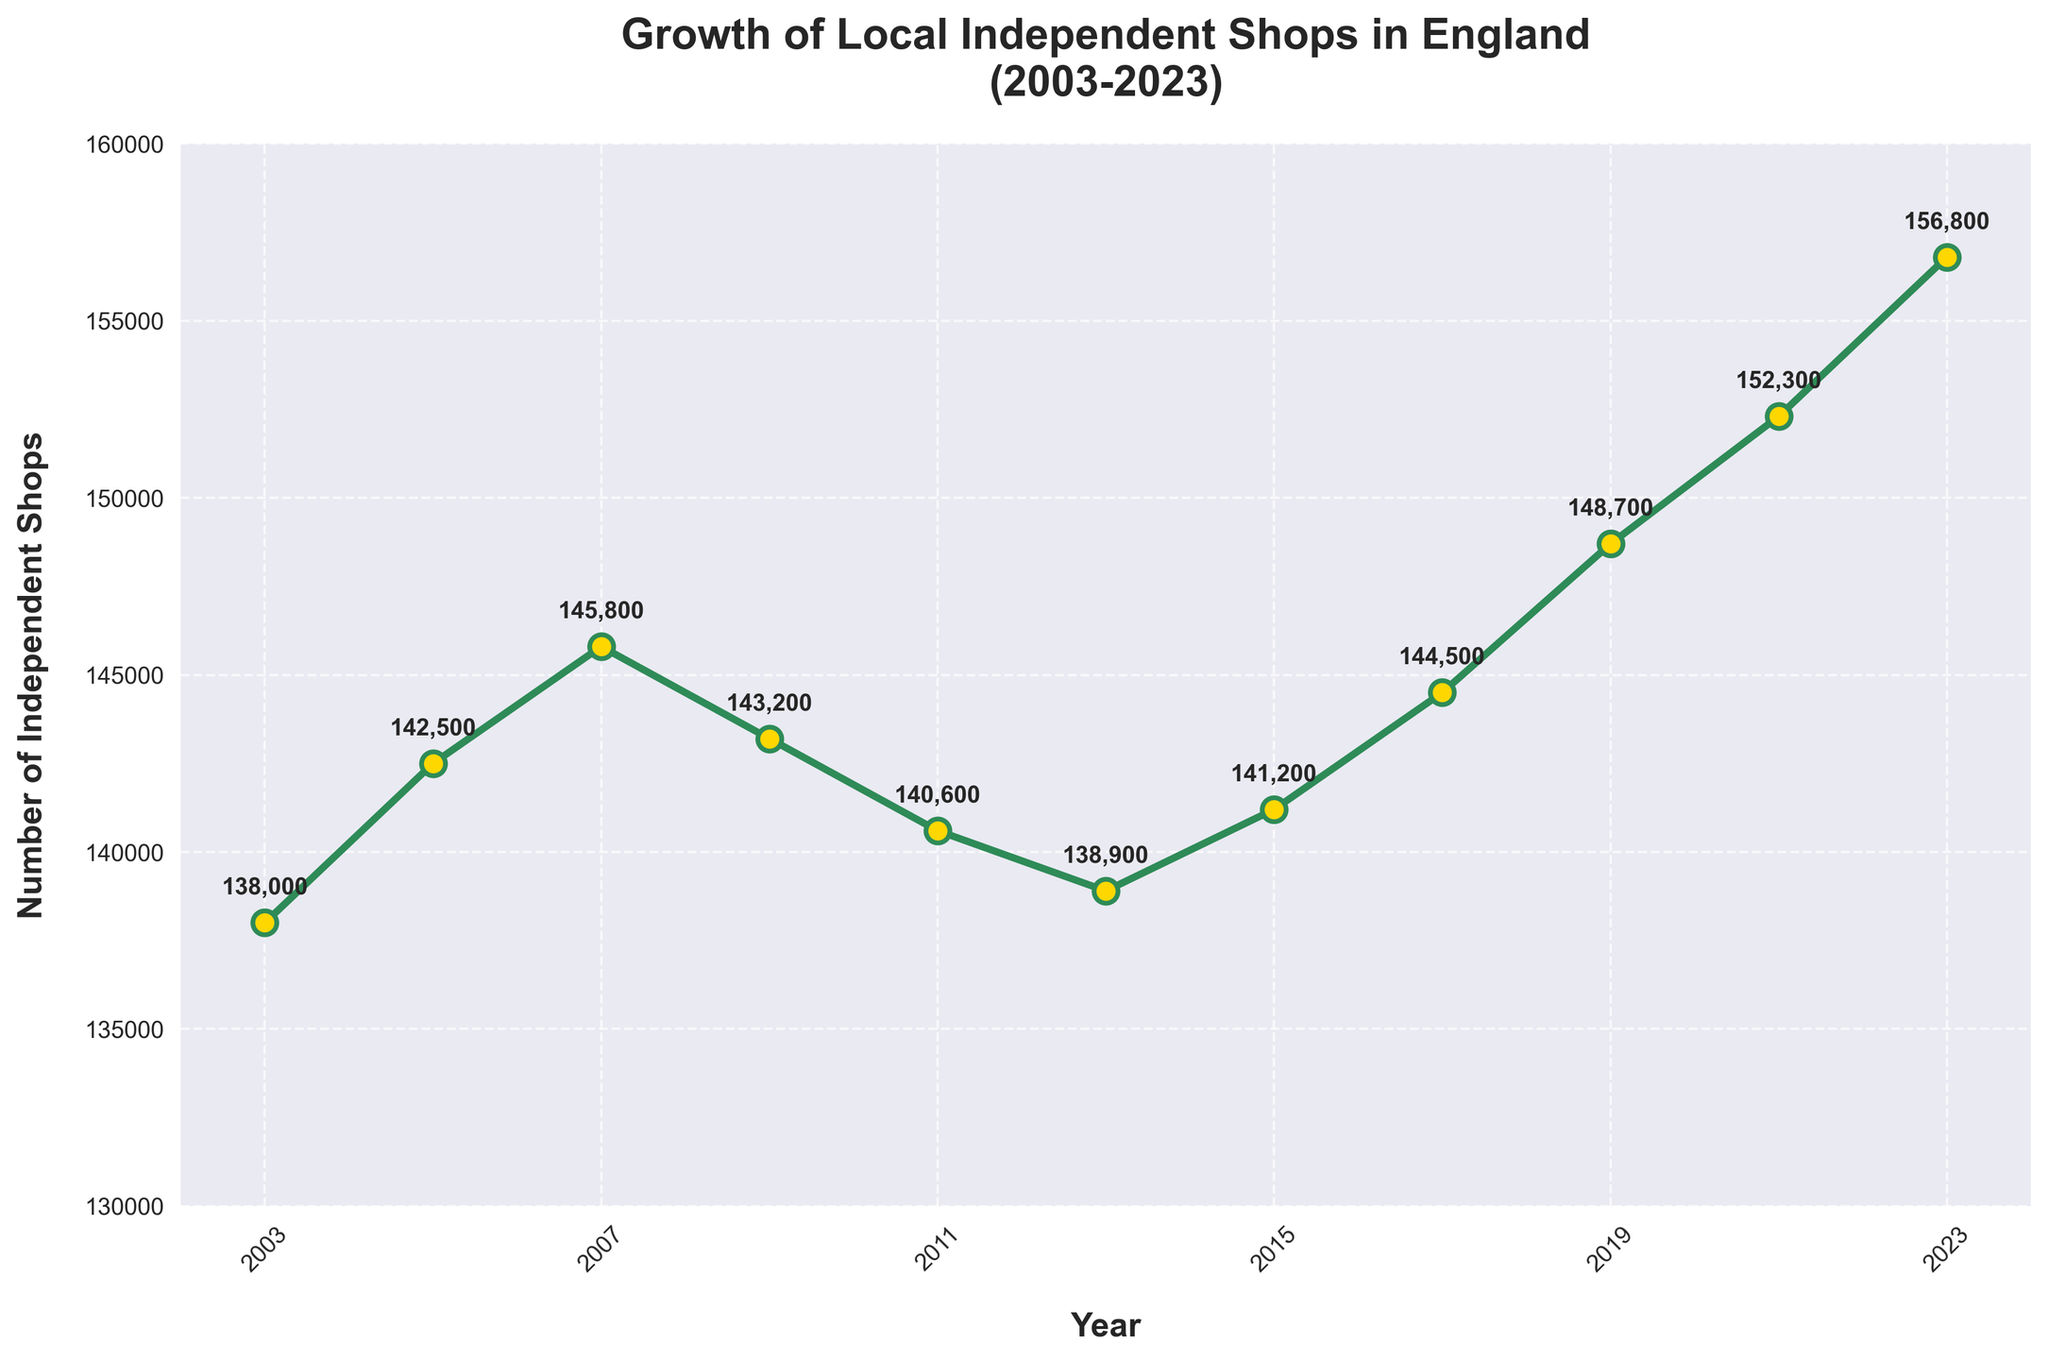What year had the highest number of independent shops? The year 2023 had the highest number of independent shops at 156,800. This is evident from the highest data point on the graph.
Answer: 2023 What is the difference in the number of independent shops between 2003 and 2023? To find the difference, subtract the number of independent shops in 2003 (138,000) from that in 2023 (156,800). 156,800 - 138,000 = 18,800.
Answer: 18,800 In which period did the number of shops decrease the most? The most significant decrease occurred between 2007 and 2009. The number of shops dropped from 145,800 in 2007 to 143,200 in 2009. The difference is 145,800 - 143,200 = 2,600.
Answer: Between 2007 and 2009 What is the average number of shops from 2003 to 2023? To calculate the average, sum the numbers for all the years and then divide by the number of years. Sum = 138,000 + 142,500 + 145,800 + 143,200 + 140,600 + 138,900 + 141,200 + 144,500 + 148,700 + 152,300 + 156,800 = 1,592,500. There are 11 years, so 1,592,500 / 11 = 144,772.7.
Answer: 144,772.7 Did the number of shops ever dip below 140,000? Yes, in 2013, the number of shops was 138,900, which is below 140,000. This can be seen as the lowest point on the graph.
Answer: Yes Was there ever a period where the number of shops remained the same or decreased consecutively for three years or more? No, the graph indicates that while there were periods of decrease, none lasted for three consecutive years.
Answer: No How does the growth trend from 2019 to 2023 compare to the trend from 2005 to 2007? From 2019 to 2023, the number of shops increased from 148,700 to 156,800, which is a growth of 8,100 shops. From 2005 to 2007, the increase was from 142,500 to 145,800, a growth of 3,300 shops. Thus, the growth from 2019 to 2023 is more significant.
Answer: 2019-2023 had higher growth Is the trend of the number of shops generally increasing or decreasing over the whole period? The general trend over the 20 years shows an increase in the number of independent shops. Despite some decreases in certain intervals, the overall trajectory is upward.
Answer: Increasing 